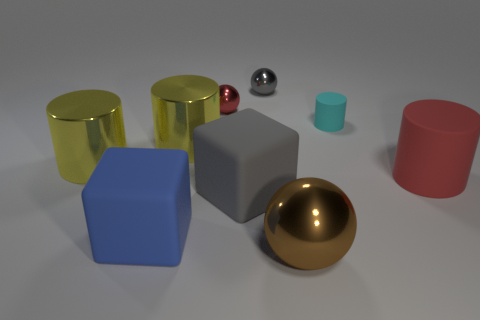Subtract 1 cylinders. How many cylinders are left? 3 Subtract all cylinders. How many objects are left? 5 Add 6 small rubber cylinders. How many small rubber cylinders exist? 7 Subtract 1 red spheres. How many objects are left? 8 Subtract all gray blocks. Subtract all tiny metallic balls. How many objects are left? 6 Add 8 big brown things. How many big brown things are left? 9 